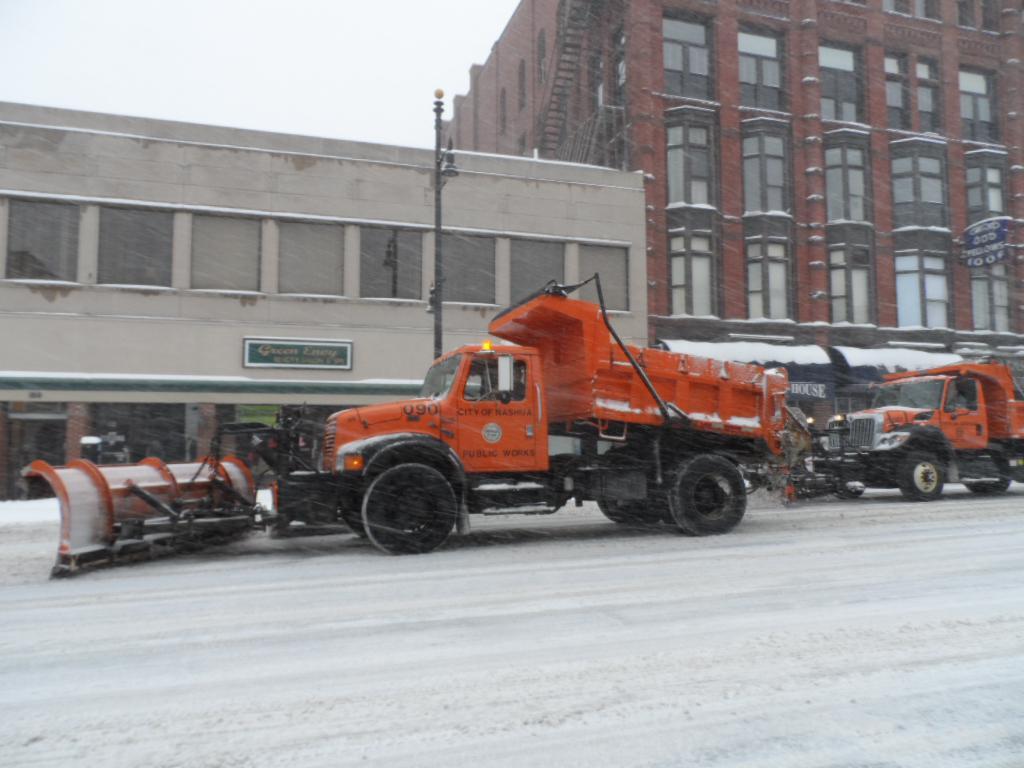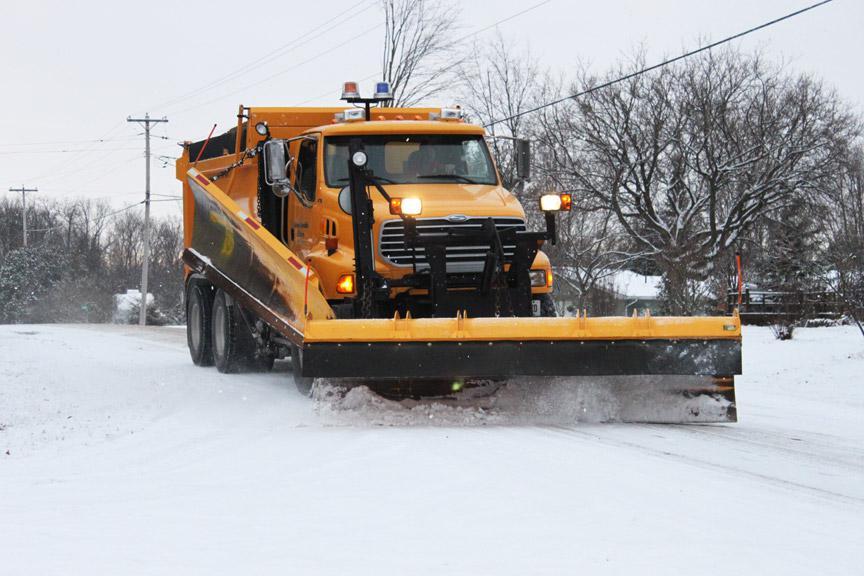The first image is the image on the left, the second image is the image on the right. For the images displayed, is the sentence "There are at most 3 trucks total." factually correct? Answer yes or no. Yes. 